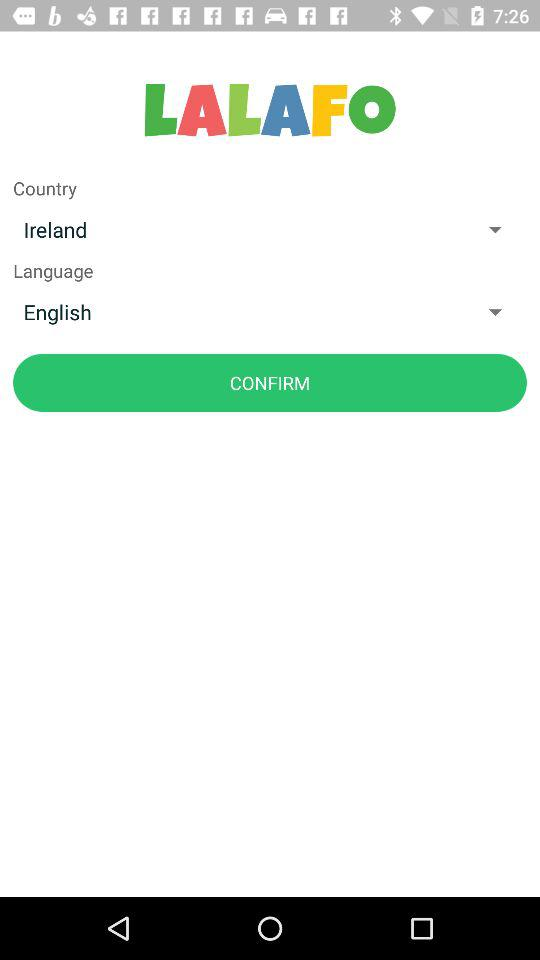What is the application name? The application name is "LALAFO". 